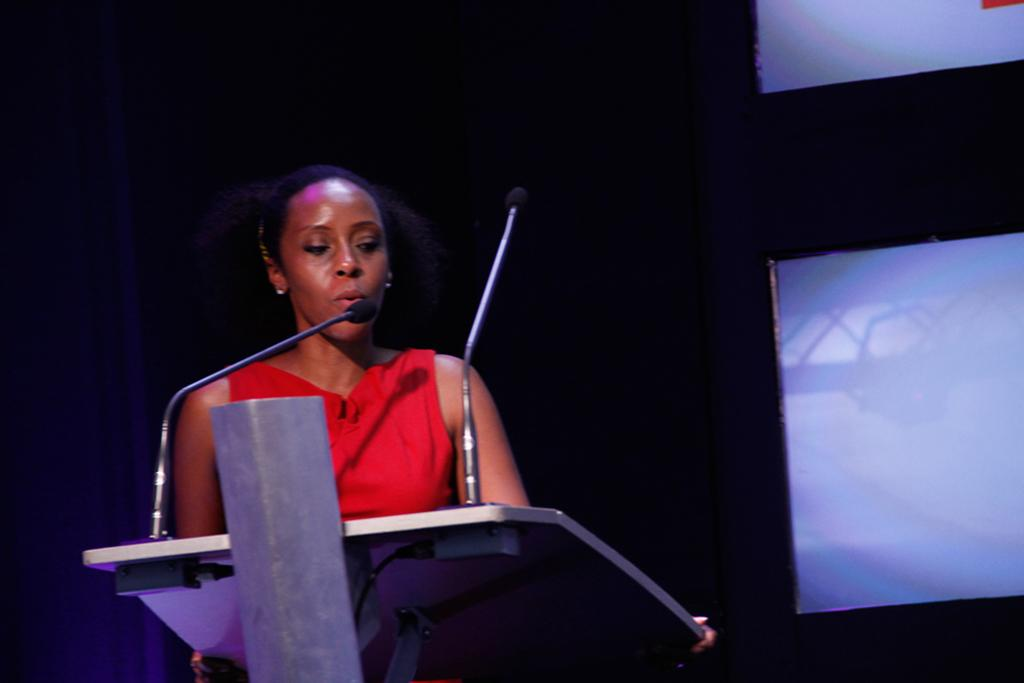Who is the main subject in the image? There is a woman in the image. What is the woman wearing? The woman is wearing a red dress. What is the woman doing in the image? The woman is standing behind a podium. What can be seen on the podium? There are two microphones on the podium. What is the color of the background in the image? The background of the image is black. How many vases are visible on the podium in the image? There are no vases present on the podium or in the image. What type of mask is the woman wearing in the image? The woman is not wearing a mask in the image. 